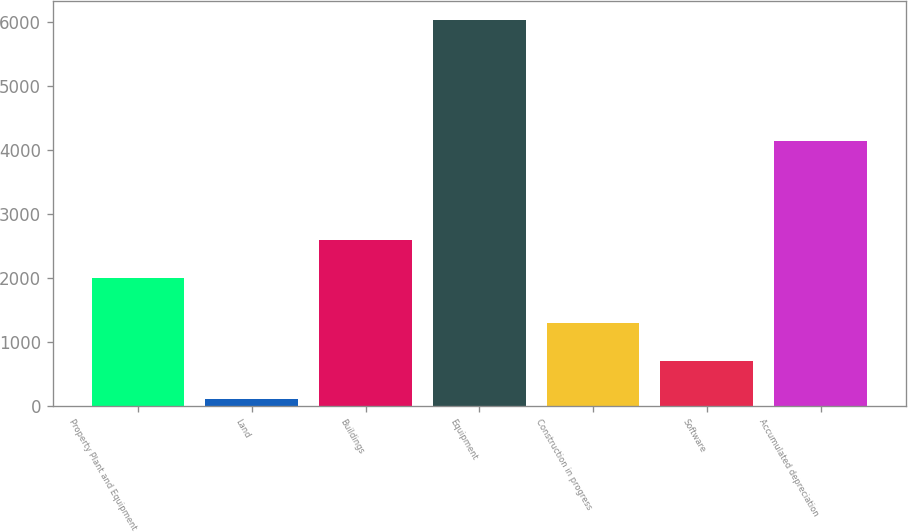Convert chart to OTSL. <chart><loc_0><loc_0><loc_500><loc_500><bar_chart><fcel>Property Plant and Equipment<fcel>Land<fcel>Buildings<fcel>Equipment<fcel>Construction in progress<fcel>Software<fcel>Accumulated depreciation<nl><fcel>2002<fcel>106.3<fcel>2593.86<fcel>6024.9<fcel>1290.02<fcel>698.16<fcel>4140.3<nl></chart> 